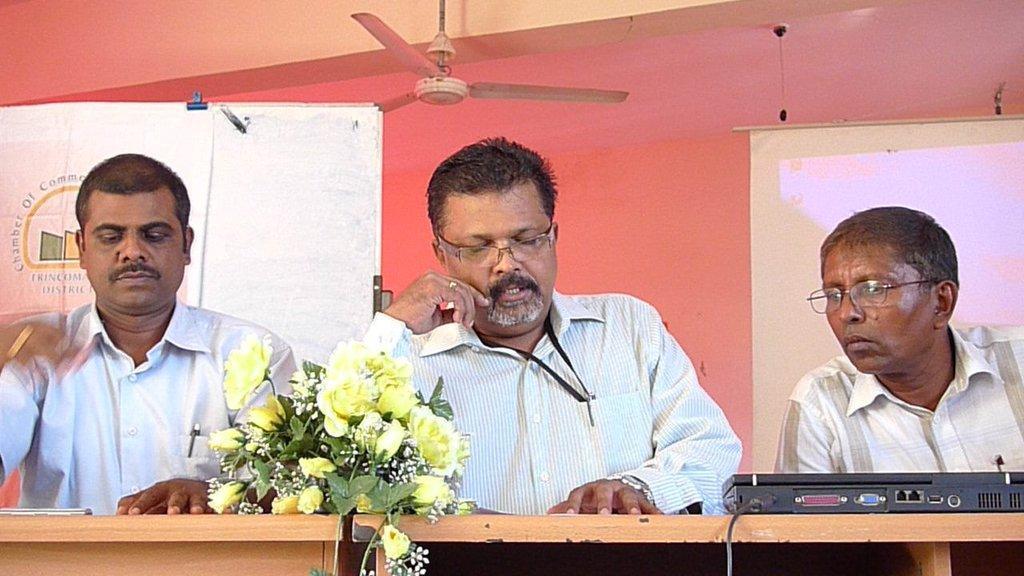In one or two sentences, can you explain what this image depicts? In the image,there are three men they are discussing something and on the table there are yellow flowers and a gadget are kept. In the background there is a pink wall and in front of the wall there is a projector and to the left side there is a board. 